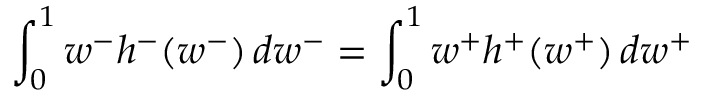Convert formula to latex. <formula><loc_0><loc_0><loc_500><loc_500>\int _ { 0 } ^ { 1 } w ^ { - } h ^ { - } ( w ^ { - } ) \, d w ^ { - } = \int _ { 0 } ^ { 1 } w ^ { + } h ^ { + } ( w ^ { + } ) \, d w ^ { + }</formula> 